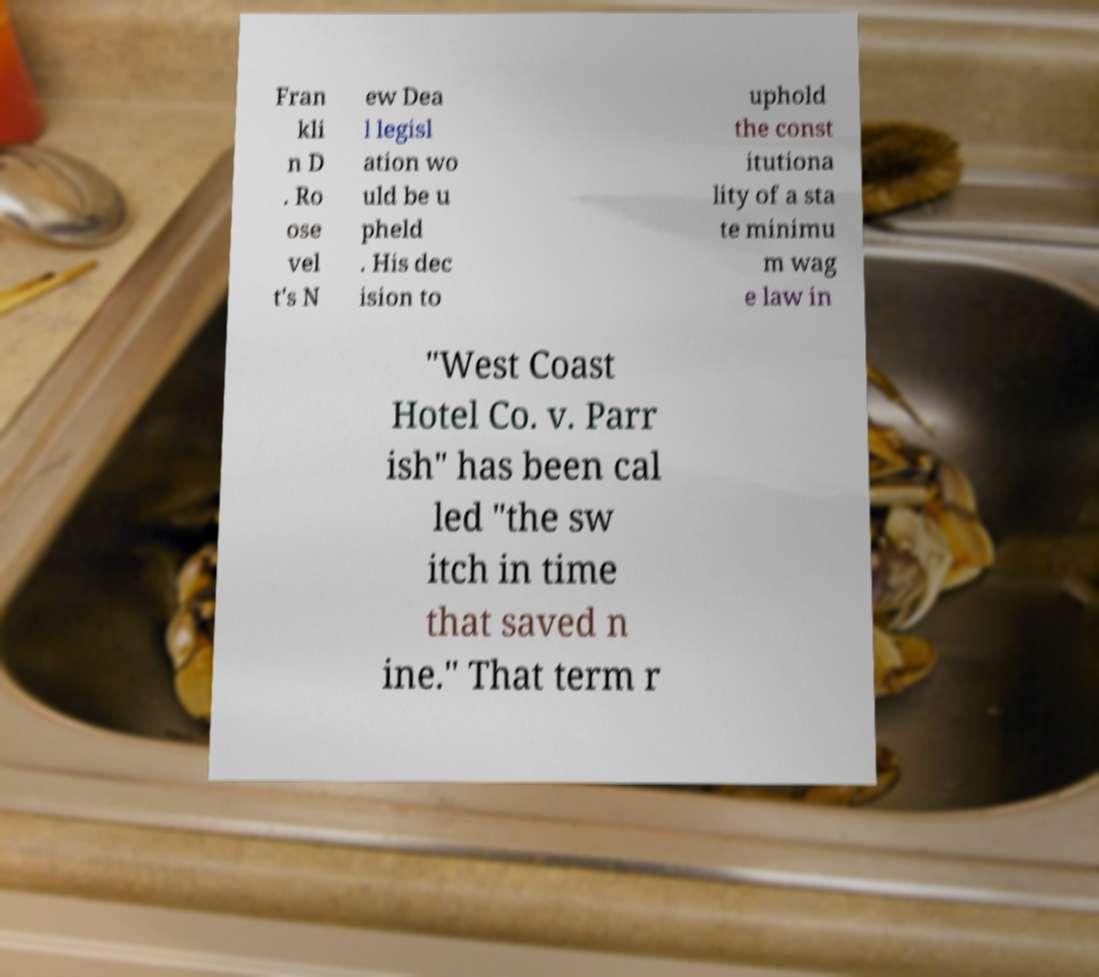What messages or text are displayed in this image? I need them in a readable, typed format. Fran kli n D . Ro ose vel t's N ew Dea l legisl ation wo uld be u pheld . His dec ision to uphold the const itutiona lity of a sta te minimu m wag e law in "West Coast Hotel Co. v. Parr ish" has been cal led "the sw itch in time that saved n ine." That term r 